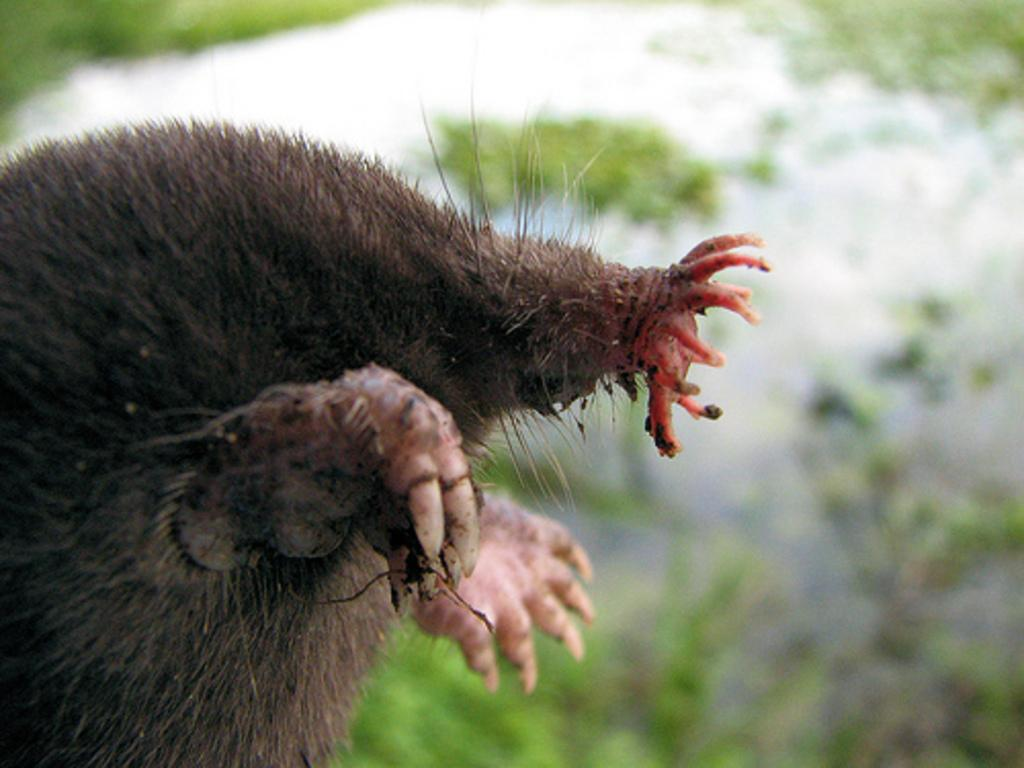What type of animal is partially visible in the image? The image shows the legs of an animal, but it is not possible to determine the specific type of animal from the provided facts. What can be observed about the background of the image? The background of the animal is blurred. What color is the scarf that the animal is holding in the image? There is no scarf present in the image. How does the kite fly in the image? There is no kite present in the image. 